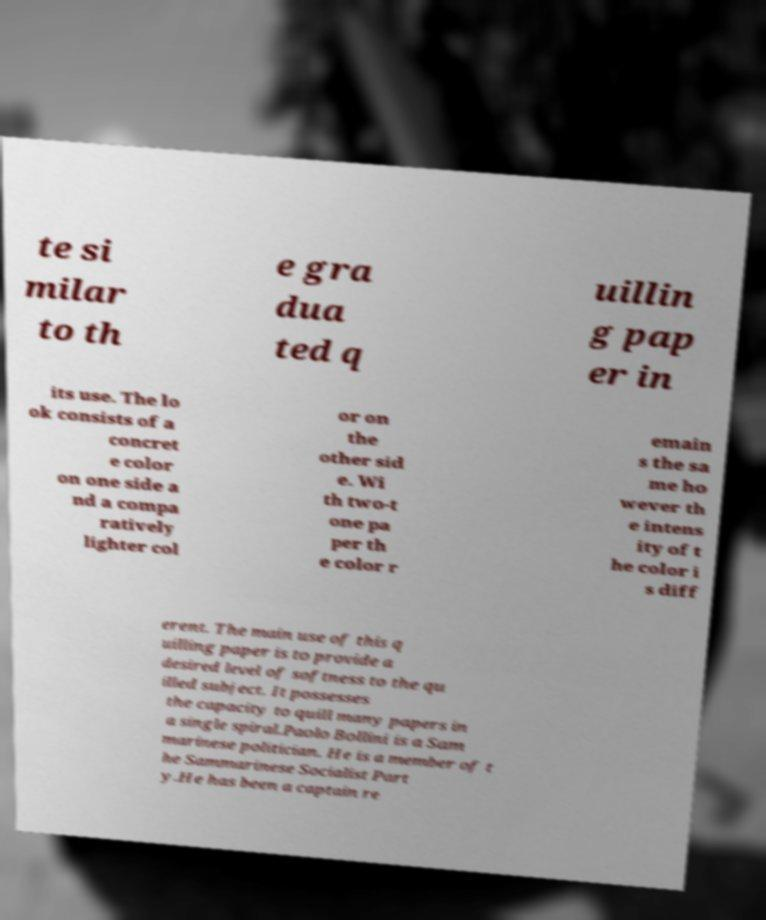Can you read and provide the text displayed in the image?This photo seems to have some interesting text. Can you extract and type it out for me? te si milar to th e gra dua ted q uillin g pap er in its use. The lo ok consists of a concret e color on one side a nd a compa ratively lighter col or on the other sid e. Wi th two-t one pa per th e color r emain s the sa me ho wever th e intens ity of t he color i s diff erent. The main use of this q uilling paper is to provide a desired level of softness to the qu illed subject. It possesses the capacity to quill many papers in a single spiral.Paolo Bollini is a Sam marinese politician. He is a member of t he Sammarinese Socialist Part y.He has been a captain re 